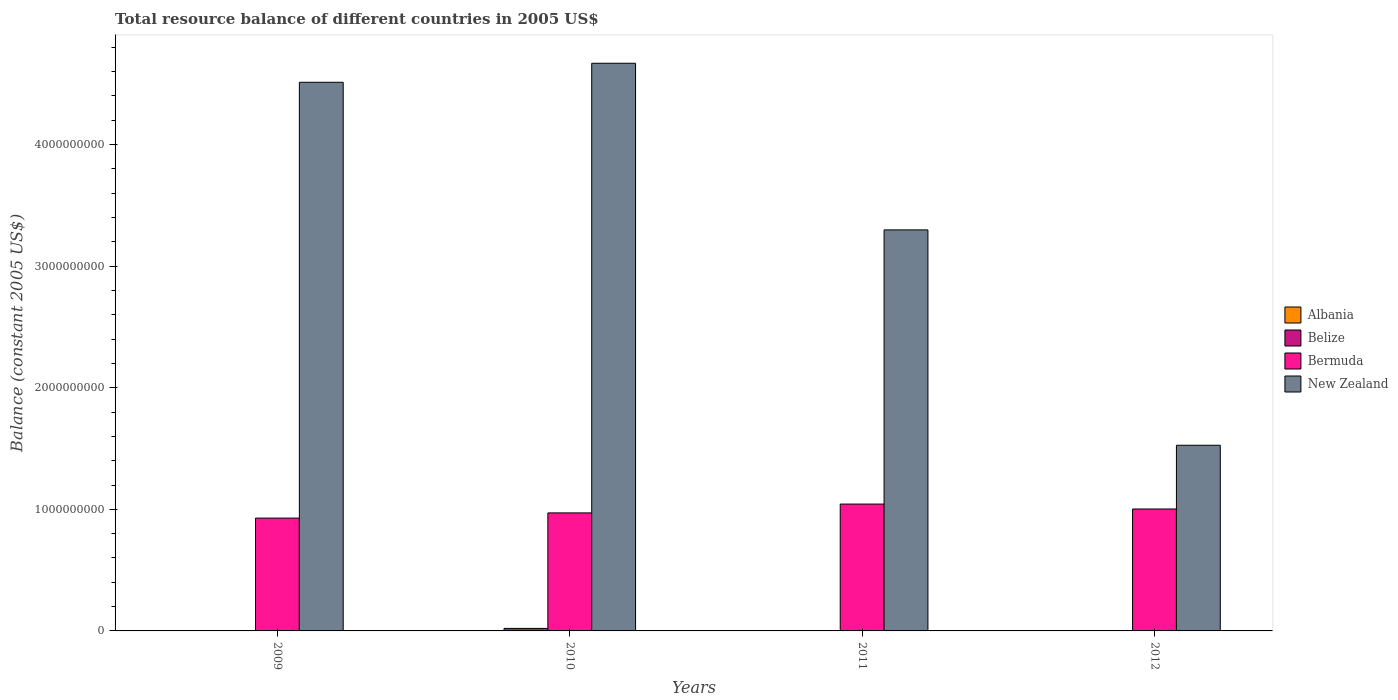How many bars are there on the 2nd tick from the right?
Your response must be concise. 2. What is the label of the 1st group of bars from the left?
Offer a very short reply. 2009. What is the total resource balance in New Zealand in 2010?
Offer a terse response. 4.67e+09. Across all years, what is the maximum total resource balance in Belize?
Offer a very short reply. 2.07e+07. Across all years, what is the minimum total resource balance in New Zealand?
Offer a terse response. 1.53e+09. In which year was the total resource balance in Belize maximum?
Offer a terse response. 2010. What is the total total resource balance in Belize in the graph?
Offer a very short reply. 2.07e+07. What is the difference between the total resource balance in Bermuda in 2011 and that in 2012?
Give a very brief answer. 4.06e+07. What is the difference between the total resource balance in Bermuda in 2010 and the total resource balance in Albania in 2012?
Offer a terse response. 9.71e+08. What is the average total resource balance in New Zealand per year?
Your answer should be compact. 3.50e+09. What is the ratio of the total resource balance in Bermuda in 2010 to that in 2012?
Offer a terse response. 0.97. Is the total resource balance in Bermuda in 2010 less than that in 2011?
Provide a succinct answer. Yes. What is the difference between the highest and the second highest total resource balance in Bermuda?
Provide a short and direct response. 4.06e+07. What is the difference between the highest and the lowest total resource balance in Belize?
Keep it short and to the point. 2.07e+07. In how many years, is the total resource balance in Albania greater than the average total resource balance in Albania taken over all years?
Provide a succinct answer. 0. Is it the case that in every year, the sum of the total resource balance in Albania and total resource balance in Bermuda is greater than the total resource balance in Belize?
Keep it short and to the point. Yes. Are all the bars in the graph horizontal?
Provide a succinct answer. No. How many years are there in the graph?
Make the answer very short. 4. Does the graph contain grids?
Offer a terse response. No. What is the title of the graph?
Offer a very short reply. Total resource balance of different countries in 2005 US$. What is the label or title of the X-axis?
Your response must be concise. Years. What is the label or title of the Y-axis?
Your answer should be very brief. Balance (constant 2005 US$). What is the Balance (constant 2005 US$) in Belize in 2009?
Offer a terse response. 0. What is the Balance (constant 2005 US$) of Bermuda in 2009?
Your answer should be compact. 9.28e+08. What is the Balance (constant 2005 US$) in New Zealand in 2009?
Provide a succinct answer. 4.51e+09. What is the Balance (constant 2005 US$) of Belize in 2010?
Your response must be concise. 2.07e+07. What is the Balance (constant 2005 US$) in Bermuda in 2010?
Offer a terse response. 9.71e+08. What is the Balance (constant 2005 US$) in New Zealand in 2010?
Give a very brief answer. 4.67e+09. What is the Balance (constant 2005 US$) in Belize in 2011?
Offer a very short reply. 0. What is the Balance (constant 2005 US$) of Bermuda in 2011?
Your response must be concise. 1.04e+09. What is the Balance (constant 2005 US$) of New Zealand in 2011?
Make the answer very short. 3.30e+09. What is the Balance (constant 2005 US$) of Belize in 2012?
Make the answer very short. 0. What is the Balance (constant 2005 US$) in Bermuda in 2012?
Provide a short and direct response. 1.00e+09. What is the Balance (constant 2005 US$) of New Zealand in 2012?
Provide a short and direct response. 1.53e+09. Across all years, what is the maximum Balance (constant 2005 US$) in Belize?
Ensure brevity in your answer.  2.07e+07. Across all years, what is the maximum Balance (constant 2005 US$) in Bermuda?
Provide a succinct answer. 1.04e+09. Across all years, what is the maximum Balance (constant 2005 US$) in New Zealand?
Offer a very short reply. 4.67e+09. Across all years, what is the minimum Balance (constant 2005 US$) in Belize?
Give a very brief answer. 0. Across all years, what is the minimum Balance (constant 2005 US$) of Bermuda?
Your answer should be very brief. 9.28e+08. Across all years, what is the minimum Balance (constant 2005 US$) of New Zealand?
Offer a terse response. 1.53e+09. What is the total Balance (constant 2005 US$) in Belize in the graph?
Give a very brief answer. 2.07e+07. What is the total Balance (constant 2005 US$) in Bermuda in the graph?
Make the answer very short. 3.94e+09. What is the total Balance (constant 2005 US$) of New Zealand in the graph?
Offer a terse response. 1.40e+1. What is the difference between the Balance (constant 2005 US$) of Bermuda in 2009 and that in 2010?
Provide a succinct answer. -4.29e+07. What is the difference between the Balance (constant 2005 US$) in New Zealand in 2009 and that in 2010?
Keep it short and to the point. -1.56e+08. What is the difference between the Balance (constant 2005 US$) of Bermuda in 2009 and that in 2011?
Give a very brief answer. -1.15e+08. What is the difference between the Balance (constant 2005 US$) in New Zealand in 2009 and that in 2011?
Offer a very short reply. 1.21e+09. What is the difference between the Balance (constant 2005 US$) in Bermuda in 2009 and that in 2012?
Your response must be concise. -7.49e+07. What is the difference between the Balance (constant 2005 US$) of New Zealand in 2009 and that in 2012?
Offer a very short reply. 2.99e+09. What is the difference between the Balance (constant 2005 US$) in Bermuda in 2010 and that in 2011?
Keep it short and to the point. -7.26e+07. What is the difference between the Balance (constant 2005 US$) in New Zealand in 2010 and that in 2011?
Ensure brevity in your answer.  1.37e+09. What is the difference between the Balance (constant 2005 US$) in Bermuda in 2010 and that in 2012?
Provide a succinct answer. -3.20e+07. What is the difference between the Balance (constant 2005 US$) of New Zealand in 2010 and that in 2012?
Your answer should be compact. 3.14e+09. What is the difference between the Balance (constant 2005 US$) of Bermuda in 2011 and that in 2012?
Offer a terse response. 4.06e+07. What is the difference between the Balance (constant 2005 US$) of New Zealand in 2011 and that in 2012?
Offer a terse response. 1.77e+09. What is the difference between the Balance (constant 2005 US$) of Bermuda in 2009 and the Balance (constant 2005 US$) of New Zealand in 2010?
Keep it short and to the point. -3.74e+09. What is the difference between the Balance (constant 2005 US$) of Bermuda in 2009 and the Balance (constant 2005 US$) of New Zealand in 2011?
Provide a succinct answer. -2.37e+09. What is the difference between the Balance (constant 2005 US$) of Bermuda in 2009 and the Balance (constant 2005 US$) of New Zealand in 2012?
Give a very brief answer. -5.99e+08. What is the difference between the Balance (constant 2005 US$) in Belize in 2010 and the Balance (constant 2005 US$) in Bermuda in 2011?
Ensure brevity in your answer.  -1.02e+09. What is the difference between the Balance (constant 2005 US$) of Belize in 2010 and the Balance (constant 2005 US$) of New Zealand in 2011?
Ensure brevity in your answer.  -3.28e+09. What is the difference between the Balance (constant 2005 US$) of Bermuda in 2010 and the Balance (constant 2005 US$) of New Zealand in 2011?
Make the answer very short. -2.33e+09. What is the difference between the Balance (constant 2005 US$) in Belize in 2010 and the Balance (constant 2005 US$) in Bermuda in 2012?
Keep it short and to the point. -9.82e+08. What is the difference between the Balance (constant 2005 US$) of Belize in 2010 and the Balance (constant 2005 US$) of New Zealand in 2012?
Provide a succinct answer. -1.51e+09. What is the difference between the Balance (constant 2005 US$) in Bermuda in 2010 and the Balance (constant 2005 US$) in New Zealand in 2012?
Ensure brevity in your answer.  -5.56e+08. What is the difference between the Balance (constant 2005 US$) of Bermuda in 2011 and the Balance (constant 2005 US$) of New Zealand in 2012?
Your answer should be very brief. -4.84e+08. What is the average Balance (constant 2005 US$) of Belize per year?
Give a very brief answer. 5.17e+06. What is the average Balance (constant 2005 US$) in Bermuda per year?
Your answer should be very brief. 9.86e+08. What is the average Balance (constant 2005 US$) in New Zealand per year?
Provide a short and direct response. 3.50e+09. In the year 2009, what is the difference between the Balance (constant 2005 US$) of Bermuda and Balance (constant 2005 US$) of New Zealand?
Offer a very short reply. -3.58e+09. In the year 2010, what is the difference between the Balance (constant 2005 US$) in Belize and Balance (constant 2005 US$) in Bermuda?
Make the answer very short. -9.50e+08. In the year 2010, what is the difference between the Balance (constant 2005 US$) of Belize and Balance (constant 2005 US$) of New Zealand?
Give a very brief answer. -4.65e+09. In the year 2010, what is the difference between the Balance (constant 2005 US$) in Bermuda and Balance (constant 2005 US$) in New Zealand?
Offer a terse response. -3.70e+09. In the year 2011, what is the difference between the Balance (constant 2005 US$) of Bermuda and Balance (constant 2005 US$) of New Zealand?
Offer a very short reply. -2.25e+09. In the year 2012, what is the difference between the Balance (constant 2005 US$) of Bermuda and Balance (constant 2005 US$) of New Zealand?
Provide a succinct answer. -5.24e+08. What is the ratio of the Balance (constant 2005 US$) in Bermuda in 2009 to that in 2010?
Make the answer very short. 0.96. What is the ratio of the Balance (constant 2005 US$) of New Zealand in 2009 to that in 2010?
Your answer should be compact. 0.97. What is the ratio of the Balance (constant 2005 US$) of Bermuda in 2009 to that in 2011?
Ensure brevity in your answer.  0.89. What is the ratio of the Balance (constant 2005 US$) of New Zealand in 2009 to that in 2011?
Make the answer very short. 1.37. What is the ratio of the Balance (constant 2005 US$) of Bermuda in 2009 to that in 2012?
Your answer should be very brief. 0.93. What is the ratio of the Balance (constant 2005 US$) in New Zealand in 2009 to that in 2012?
Your answer should be very brief. 2.96. What is the ratio of the Balance (constant 2005 US$) in Bermuda in 2010 to that in 2011?
Ensure brevity in your answer.  0.93. What is the ratio of the Balance (constant 2005 US$) in New Zealand in 2010 to that in 2011?
Make the answer very short. 1.42. What is the ratio of the Balance (constant 2005 US$) in Bermuda in 2010 to that in 2012?
Provide a short and direct response. 0.97. What is the ratio of the Balance (constant 2005 US$) of New Zealand in 2010 to that in 2012?
Your answer should be very brief. 3.06. What is the ratio of the Balance (constant 2005 US$) of Bermuda in 2011 to that in 2012?
Provide a short and direct response. 1.04. What is the ratio of the Balance (constant 2005 US$) in New Zealand in 2011 to that in 2012?
Keep it short and to the point. 2.16. What is the difference between the highest and the second highest Balance (constant 2005 US$) in Bermuda?
Ensure brevity in your answer.  4.06e+07. What is the difference between the highest and the second highest Balance (constant 2005 US$) of New Zealand?
Keep it short and to the point. 1.56e+08. What is the difference between the highest and the lowest Balance (constant 2005 US$) of Belize?
Your answer should be compact. 2.07e+07. What is the difference between the highest and the lowest Balance (constant 2005 US$) of Bermuda?
Give a very brief answer. 1.15e+08. What is the difference between the highest and the lowest Balance (constant 2005 US$) of New Zealand?
Give a very brief answer. 3.14e+09. 